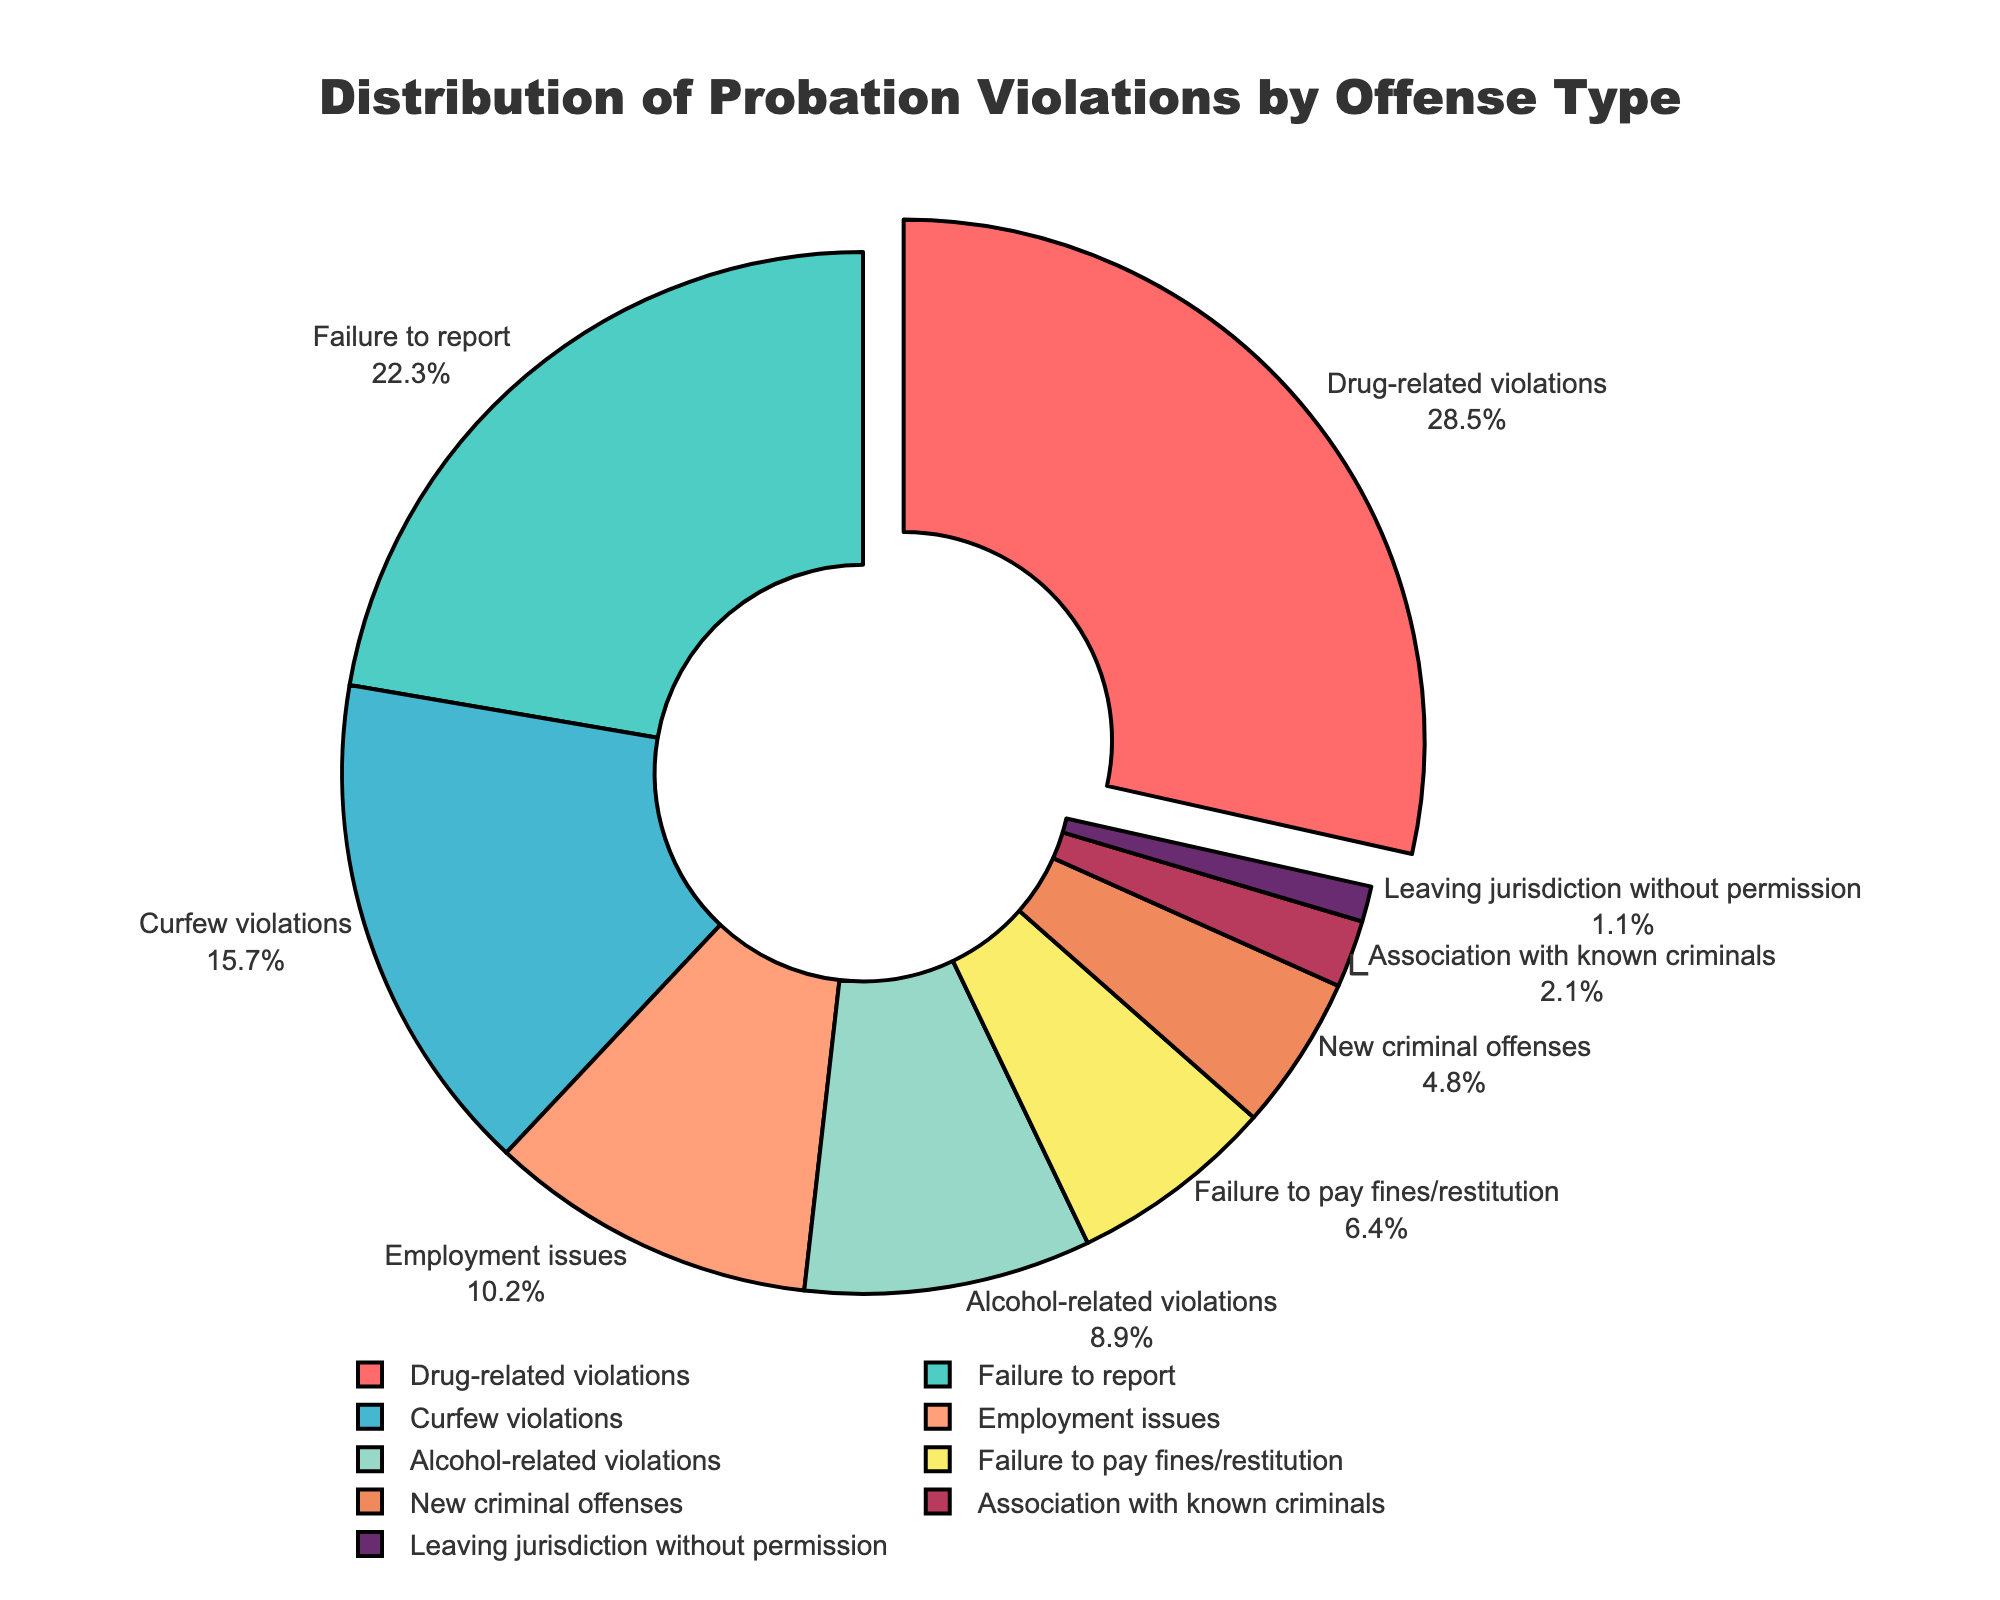What's the most common type of probation violation? The chart shows that the largest slice of the pie, representing 28.5%, is for drug-related violations, which is the highest percentage among all categories.
Answer: Drug-related violations Which offense type has the lowest percentage of probation violations? The smallest slice of the pie chart corresponds to leaving jurisdiction without permission, which has a percentage of 1.1%.
Answer: Leaving jurisdiction without permission What is the combined percentage of drug-related violations and failure to report? The pie chart shows drug-related violations at 28.5% and failure to report at 22.3%. Adding them together: 28.5% + 22.3% = 50.8%.
Answer: 50.8% Are curfew violations more common than alcohol-related violations? The pie chart shows that curfew violations occupy 15.7% while alcohol-related violations account for 8.9%. Since 15.7% is greater than 8.9%, curfew violations are more common.
Answer: Yes Which two types of offenses have approximately the same percentage? Curfew violations are at 15.7% and employment issues are at 10.2%. They are not the closest, but among the available data, they are relatively closer in value compared to others.
Answer: None are approximately the same What's the difference in percentage between the most and least common probation violation types? The most common type is drug-related violations at 28.5%, and the least common is leaving jurisdiction without permission at 1.1%. Subtracting these: 28.5% - 1.1% = 27.4%.
Answer: 27.4% What is the second most common type of probation violation and its percentage? The pie chart shows that the second largest slice after drug-related violations (28.5%) is failure to report, at 22.3%.
Answer: Failure to report (22.3%) How much more common are drug-related violations compared to new criminal offenses? The pie chart shows drug-related violations at 28.5% and new criminal offenses at 4.8%. Subtracting the two: 28.5% - 4.8% = 23.7%.
Answer: 23.7% What is the combined percentage of employment issues, alcohol-related violations, and failure to pay fines/restitution? Adding the percentages from the pie chart: employment issues (10.2%), alcohol-related violations (8.9%), and failure to pay fines/restitution (6.4%) give 10.2% + 8.9% + 6.4% = 25.5%.
Answer: 25.5% What percentage of violations are related to substance abuse (alcohol and drug-related violaitons)? Combining the percentages for drug-related violations and alcohol-related violations from the pie chart: 28.5% (drug-related) + 8.9% (alcohol-related) = 37.4%.
Answer: 37.4% 